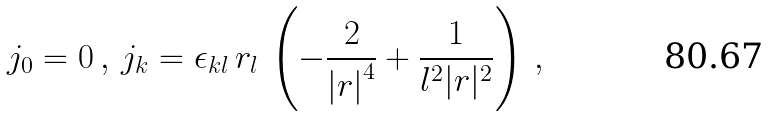<formula> <loc_0><loc_0><loc_500><loc_500>j _ { 0 } = 0 \, , \, j _ { k } = \epsilon _ { k l } \, r _ { l } \, \left ( - \frac { 2 } { \left | r \right | ^ { 4 } } + \frac { 1 } { l ^ { 2 } | r | ^ { 2 } } \right ) \, ,</formula> 